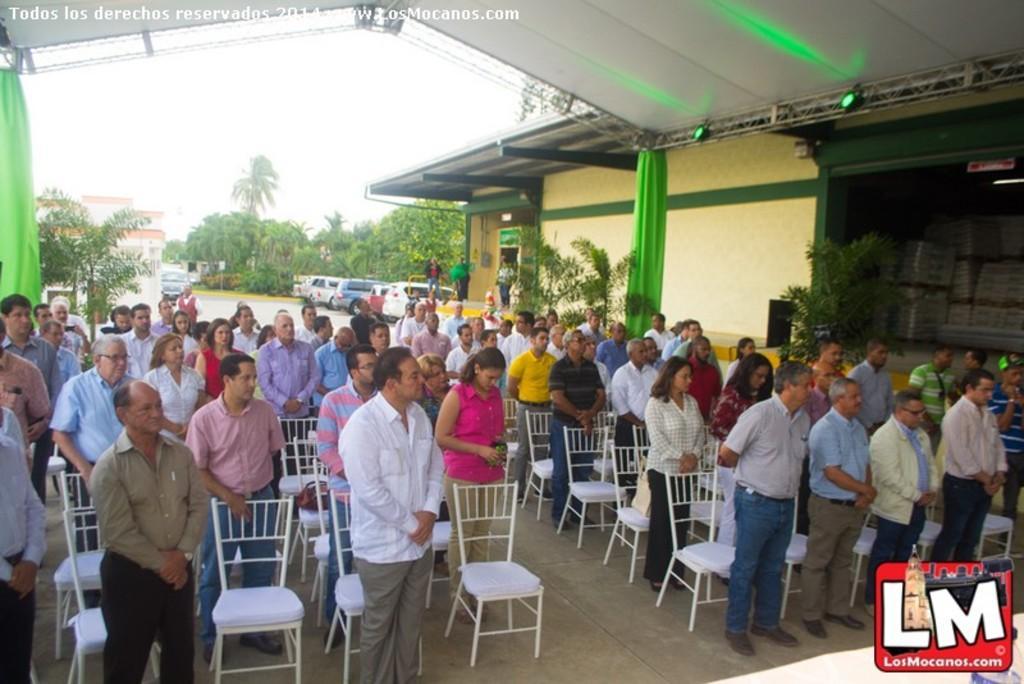What are the main subjects in the center of the image? There are people standing in the center of the image. What can be seen in the background of the image? There are trees, cars, and buildings in the background of the image. Is there a river flowing through the image? There is no river visible in the image. What type of music is being played by the band in the image? There is no band present in the image. 